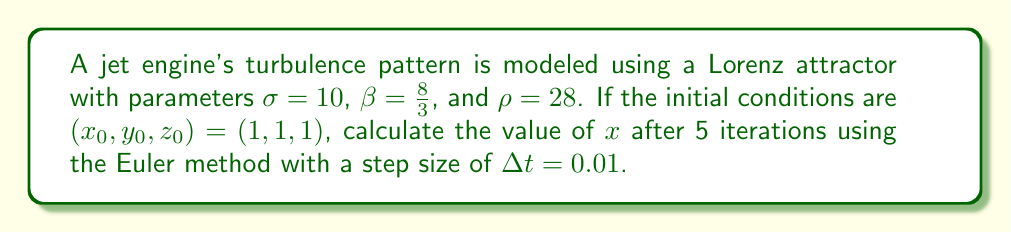Can you solve this math problem? 1. The Lorenz system is defined by the following equations:

   $$\frac{dx}{dt} = \sigma(y - x)$$
   $$\frac{dy}{dt} = x(\rho - z) - y$$
   $$\frac{dz}{dt} = xy - \beta z$$

2. The Euler method for solving these equations is:

   $$x_{n+1} = x_n + \Delta t \cdot \frac{dx}{dt}$$
   $$y_{n+1} = y_n + \Delta t \cdot \frac{dy}{dt}$$
   $$z_{n+1} = z_n + \Delta t \cdot \frac{dz}{dt}$$

3. Let's calculate the first iteration:

   $\frac{dx}{dt} = 10(1 - 1) = 0$
   $\frac{dy}{dt} = 1(28 - 1) - 1 = 26$
   $\frac{dz}{dt} = 1 \cdot 1 - \frac{8}{3} \cdot 1 = -\frac{5}{3}$

   $x_1 = 1 + 0.01 \cdot 0 = 1$
   $y_1 = 1 + 0.01 \cdot 26 = 1.26$
   $z_1 = 1 + 0.01 \cdot (-\frac{5}{3}) = 0.98333$

4. Second iteration:

   $\frac{dx}{dt} = 10(1.26 - 1) = 2.6$
   $\frac{dy}{dt} = 1(28 - 0.98333) - 1.26 = 25.75667$
   $\frac{dz}{dt} = 1 \cdot 1.26 - \frac{8}{3} \cdot 0.98333 = -1.35556$

   $x_2 = 1 + 0.01 \cdot 2.6 = 1.026$
   $y_2 = 1.26 + 0.01 \cdot 25.75667 = 1.51757$
   $z_2 = 0.98333 + 0.01 \cdot (-1.35556) = 0.96978$

5. Third iteration:

   $\frac{dx}{dt} = 10(1.51757 - 1.026) = 4.9157$
   $\frac{dy}{dt} = 1.026(28 - 0.96978) - 1.51757 = 26.13073$
   $\frac{dz}{dt} = 1.026 \cdot 1.51757 - \frac{8}{3} \cdot 0.96978 = 0.80912$

   $x_3 = 1.026 + 0.01 \cdot 4.9157 = 1.07516$
   $y_3 = 1.51757 + 0.01 \cdot 26.13073 = 1.77888$
   $z_3 = 0.96978 + 0.01 \cdot 0.80912 = 0.97787$

6. Fourth iteration:

   $\frac{dx}{dt} = 10(1.77888 - 1.07516) = 7.0372$
   $\frac{dy}{dt} = 1.07516(28 - 0.97787) - 1.77888 = 27.21175$
   $\frac{dz}{dt} = 1.07516 \cdot 1.77888 - \frac{8}{3} \cdot 0.97787 = 1.30945$

   $x_4 = 1.07516 + 0.01 \cdot 7.0372 = 1.14553$
   $y_4 = 1.77888 + 0.01 \cdot 27.21175 = 2.05100$
   $z_4 = 0.97787 + 0.01 \cdot 1.30945 = 0.99097$

7. Fifth iteration:

   $\frac{dx}{dt} = 10(2.05100 - 1.14553) = 9.0547$
   $\frac{dy}{dt} = 1.14553(28 - 0.99097) - 2.05100 = 28.04043$
   $\frac{dz}{dt} = 1.14553 \cdot 2.05100 - \frac{8}{3} \cdot 0.99097 = 1.70749$

   $x_5 = 1.14553 + 0.01 \cdot 9.0547 = 1.23608$
   $y_5 = 2.05100 + 0.01 \cdot 28.04043 = 2.33140$
   $z_5 = 0.99097 + 0.01 \cdot 1.70749 = 1.00804$

The value of x after 5 iterations is 1.23608.
Answer: 1.23608 